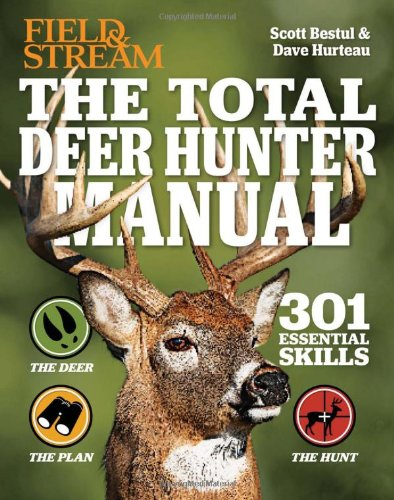What is the title of this book? The title of the book is 'The Total Deer Hunter Manual (Field & Stream): 301 Hunting Skills You Need', a comprehensive guide catering to hunting enthusiasts. 